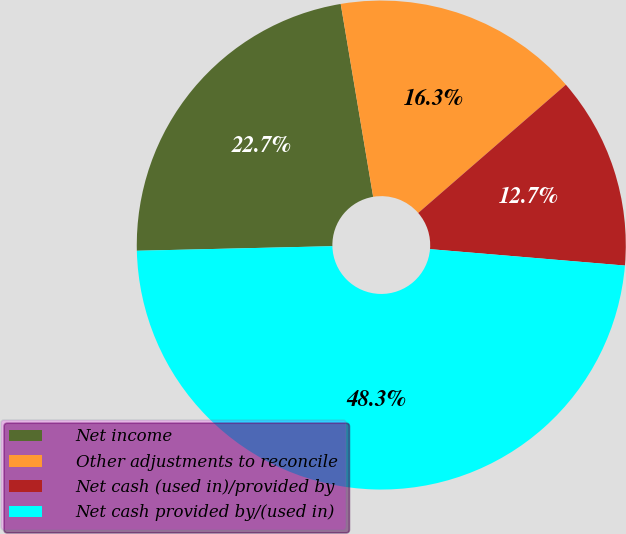<chart> <loc_0><loc_0><loc_500><loc_500><pie_chart><fcel>Net income<fcel>Other adjustments to reconcile<fcel>Net cash (used in)/provided by<fcel>Net cash provided by/(used in)<nl><fcel>22.72%<fcel>16.27%<fcel>12.72%<fcel>48.29%<nl></chart> 